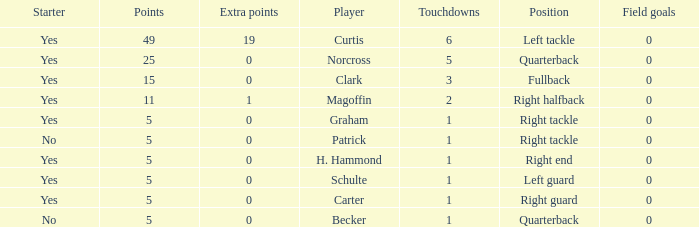Name the least touchdowns for 11 points 2.0. 